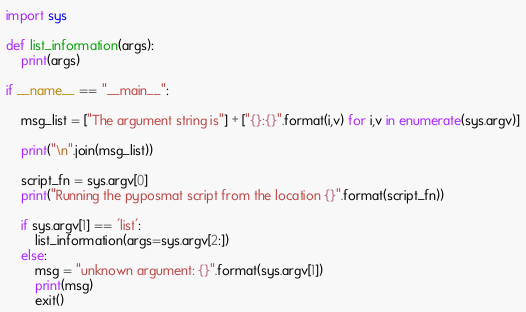<code> <loc_0><loc_0><loc_500><loc_500><_Python_>import sys

def list_information(args):
    print(args)

if __name__ == "__main__":

    msg_list = ["The argument string is"] + ["{}:{}".format(i,v) for i,v in enumerate(sys.argv)]

    print("\n".join(msg_list))
    
    script_fn = sys.argv[0]
    print("Running the pyposmat script from the location {}".format(script_fn))

    if sys.argv[1] == 'list':
        list_information(args=sys.argv[2:])
    else:
        msg = "unknown argument: {}".format(sys.argv[1])
        print(msg)
        exit()
</code> 